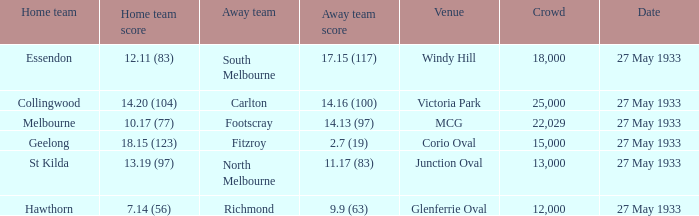During st kilda's home game, what was the number of people in the crowd? 13000.0. 